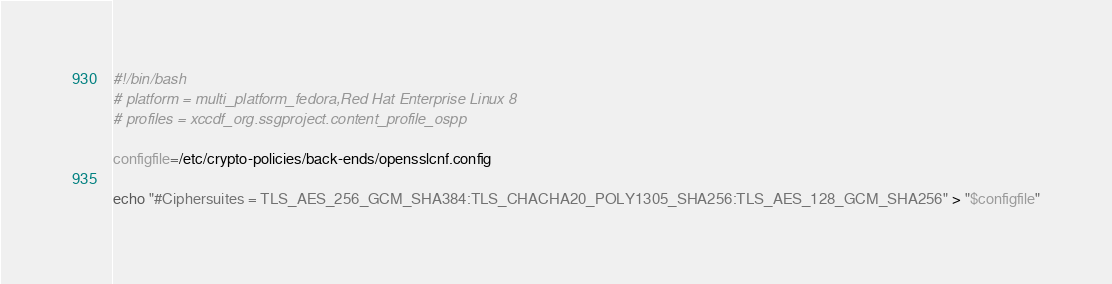<code> <loc_0><loc_0><loc_500><loc_500><_Bash_>#!/bin/bash
# platform = multi_platform_fedora,Red Hat Enterprise Linux 8
# profiles = xccdf_org.ssgproject.content_profile_ospp

configfile=/etc/crypto-policies/back-ends/opensslcnf.config

echo "#Ciphersuites = TLS_AES_256_GCM_SHA384:TLS_CHACHA20_POLY1305_SHA256:TLS_AES_128_GCM_SHA256" > "$configfile"
</code> 